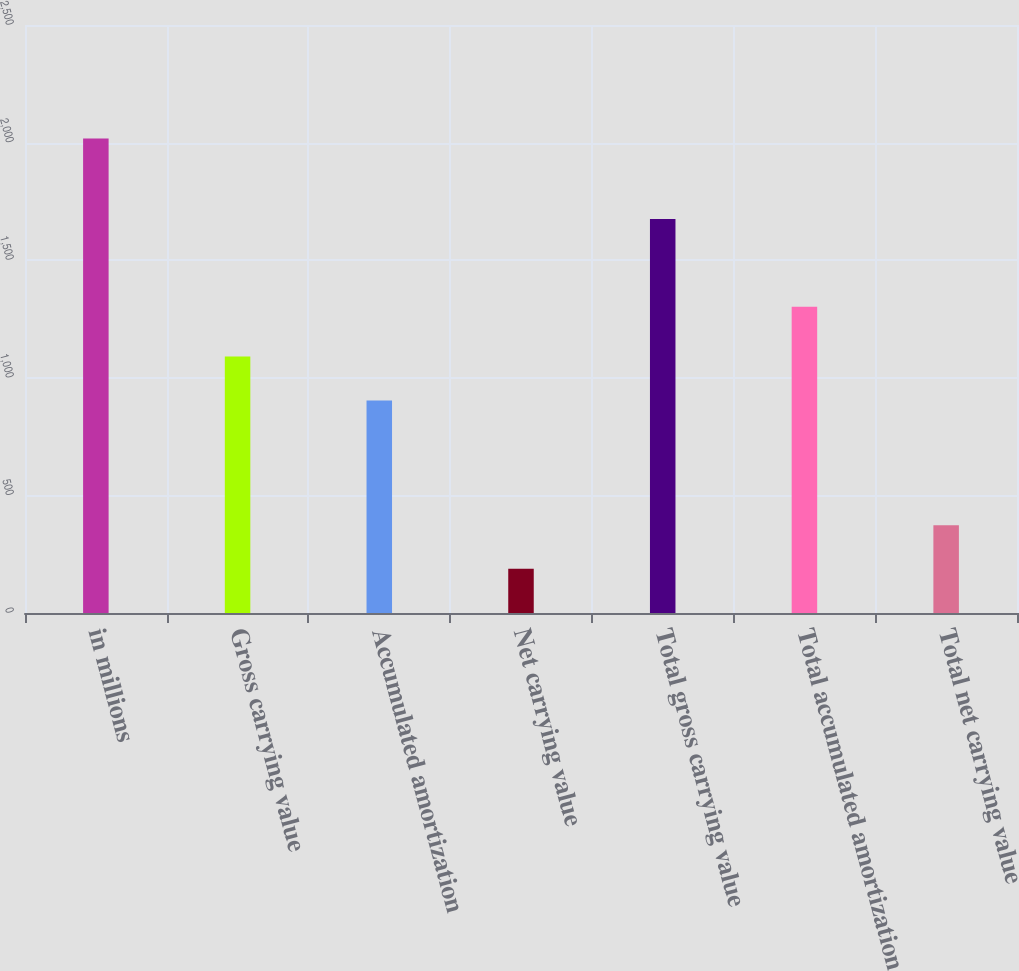Convert chart to OTSL. <chart><loc_0><loc_0><loc_500><loc_500><bar_chart><fcel>in millions<fcel>Gross carrying value<fcel>Accumulated amortization<fcel>Net carrying value<fcel>Total gross carrying value<fcel>Total accumulated amortization<fcel>Total net carrying value<nl><fcel>2017<fcel>1091<fcel>903<fcel>188<fcel>1675<fcel>1302<fcel>373<nl></chart> 